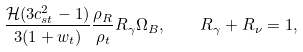Convert formula to latex. <formula><loc_0><loc_0><loc_500><loc_500>\frac { { \mathcal { H } } ( 3 c _ { s t } ^ { 2 } - 1 ) } { 3 ( 1 + w _ { t } ) } \frac { \rho _ { R } } { \rho _ { t } } R _ { \gamma } \Omega _ { B } , \quad R _ { \gamma } + R _ { \nu } = 1 ,</formula> 